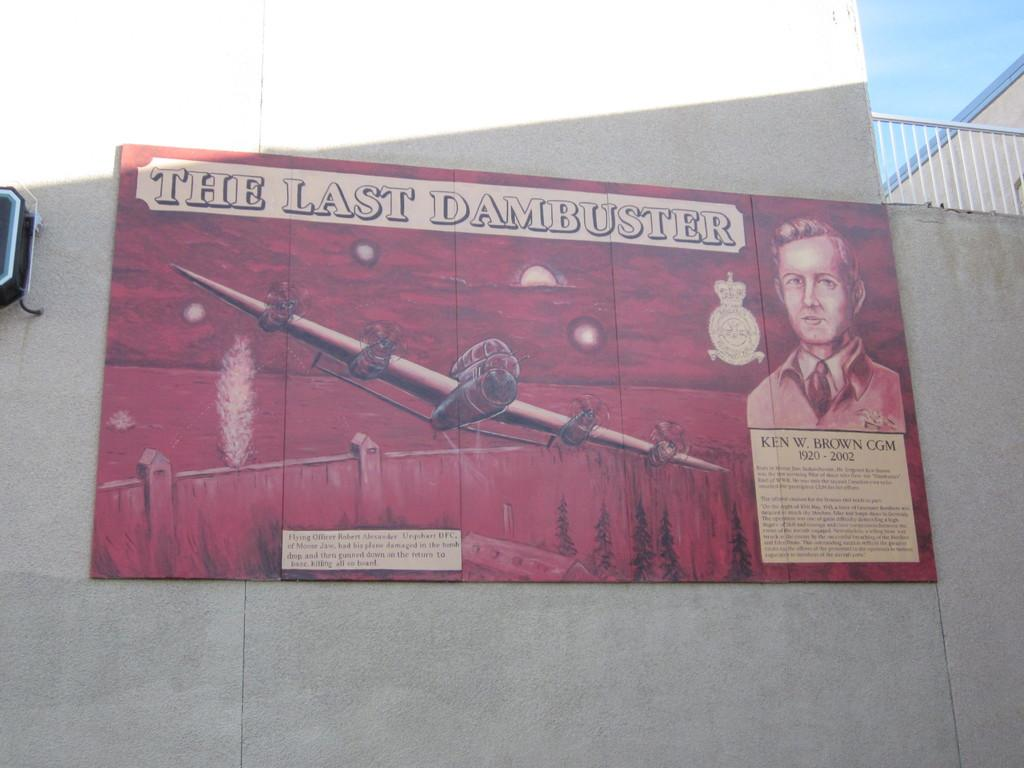<image>
Render a clear and concise summary of the photo. An old style art billboard with a plane advertising The Last Dambuster 